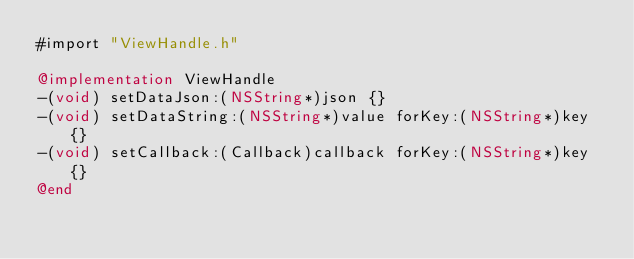Convert code to text. <code><loc_0><loc_0><loc_500><loc_500><_ObjectiveC_>#import "ViewHandle.h"

@implementation ViewHandle
-(void) setDataJson:(NSString*)json {}
-(void) setDataString:(NSString*)value forKey:(NSString*)key {}
-(void) setCallback:(Callback)callback forKey:(NSString*)key {}
@end</code> 